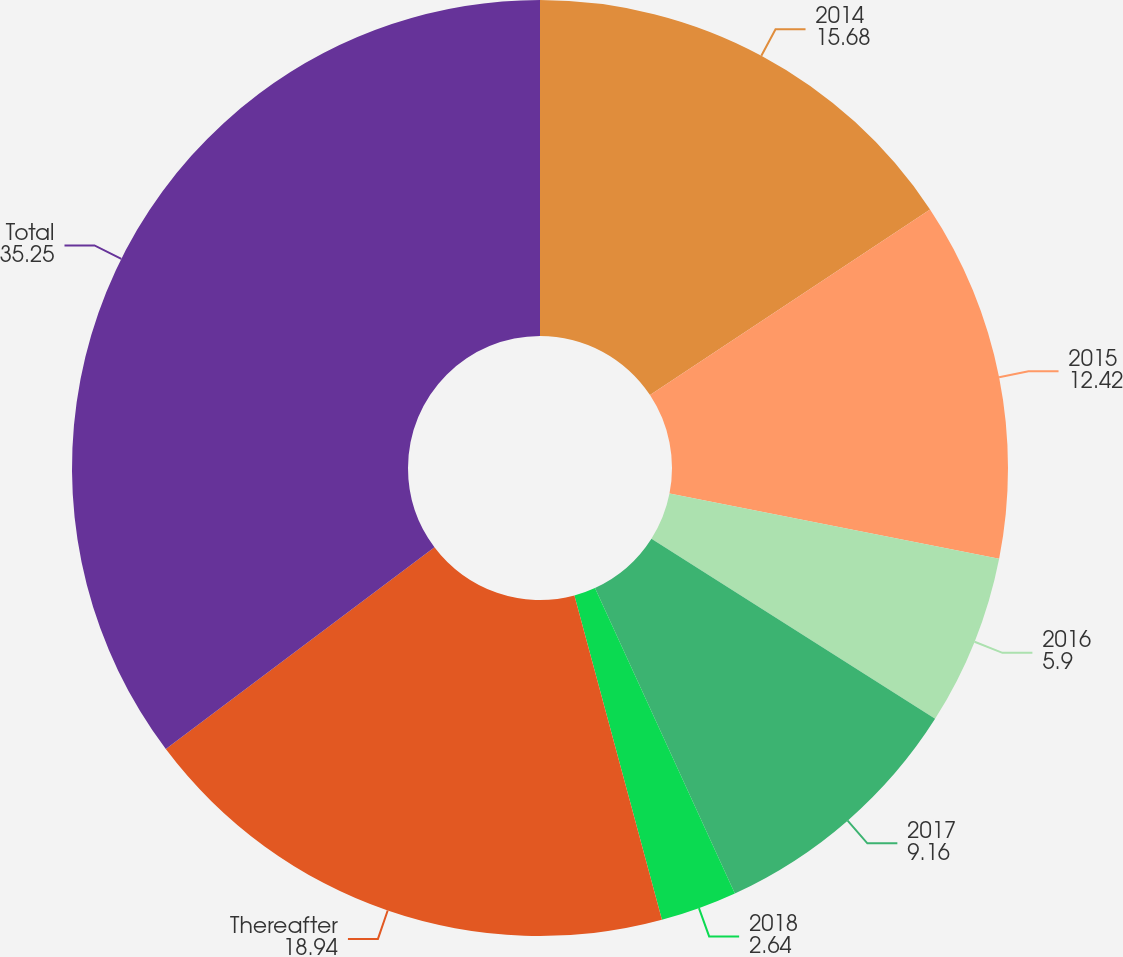Convert chart. <chart><loc_0><loc_0><loc_500><loc_500><pie_chart><fcel>2014<fcel>2015<fcel>2016<fcel>2017<fcel>2018<fcel>Thereafter<fcel>Total<nl><fcel>15.68%<fcel>12.42%<fcel>5.9%<fcel>9.16%<fcel>2.64%<fcel>18.94%<fcel>35.25%<nl></chart> 